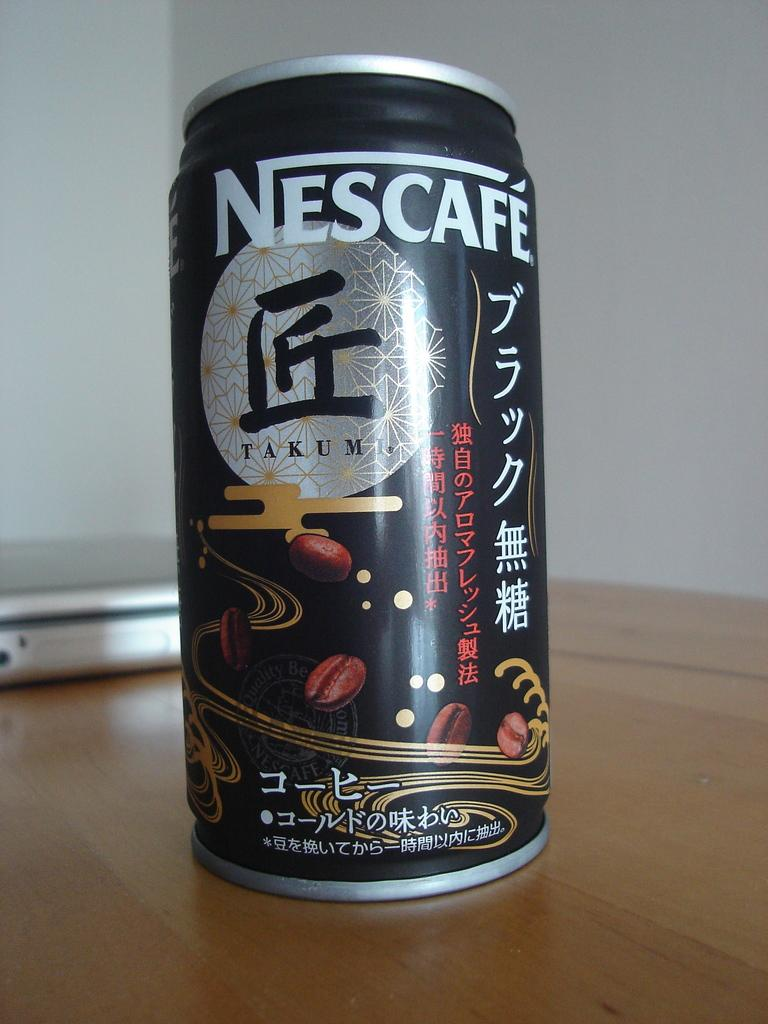<image>
Render a clear and concise summary of the photo. A can of drink with the word Nescafe along the top. 